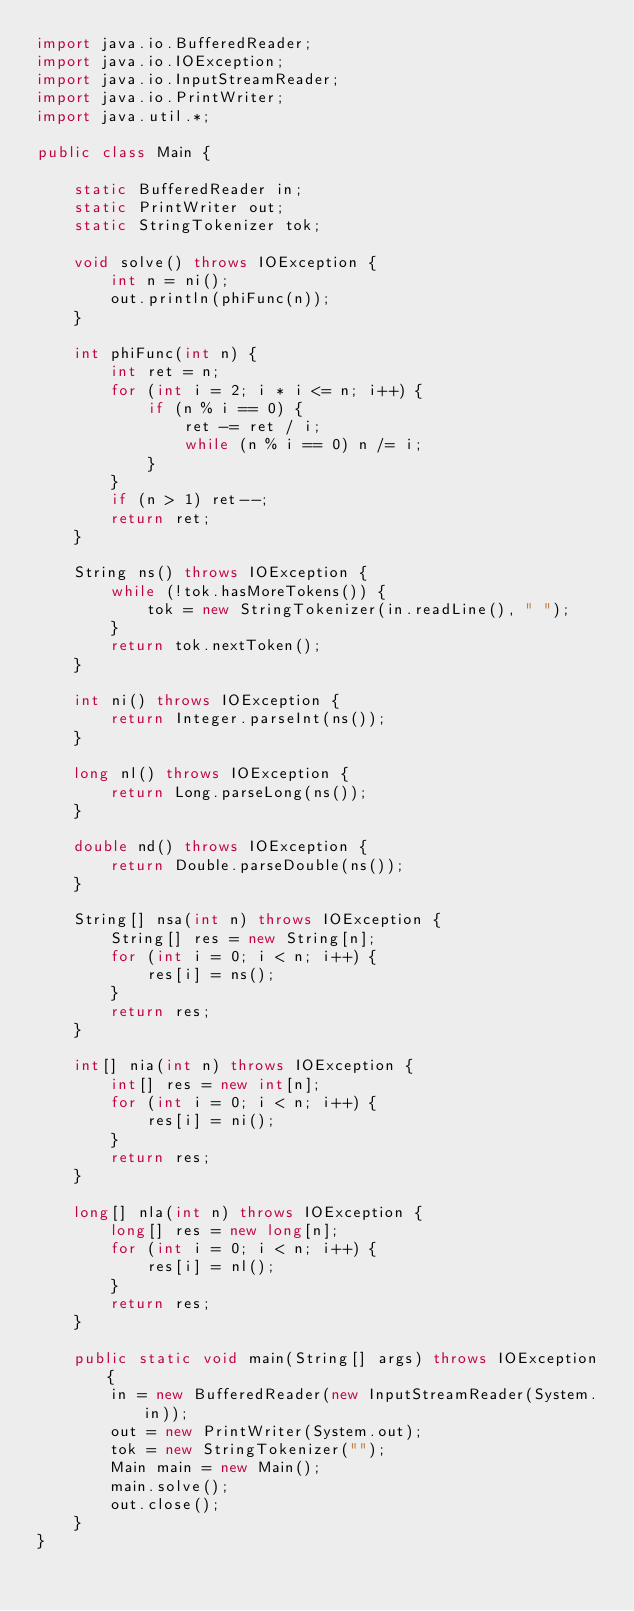<code> <loc_0><loc_0><loc_500><loc_500><_Java_>import java.io.BufferedReader;
import java.io.IOException;
import java.io.InputStreamReader;
import java.io.PrintWriter;
import java.util.*;

public class Main {

    static BufferedReader in;
    static PrintWriter out;
    static StringTokenizer tok;

    void solve() throws IOException {
        int n = ni();
        out.println(phiFunc(n));
    }

    int phiFunc(int n) {
        int ret = n;
        for (int i = 2; i * i <= n; i++) {
            if (n % i == 0) {
                ret -= ret / i;
                while (n % i == 0) n /= i;
            }
        }
        if (n > 1) ret--;
        return ret;
    }

    String ns() throws IOException {
        while (!tok.hasMoreTokens()) {
            tok = new StringTokenizer(in.readLine(), " ");
        }
        return tok.nextToken();
    }

    int ni() throws IOException {
        return Integer.parseInt(ns());
    }

    long nl() throws IOException {
        return Long.parseLong(ns());
    }

    double nd() throws IOException {
        return Double.parseDouble(ns());
    }

    String[] nsa(int n) throws IOException {
        String[] res = new String[n];
        for (int i = 0; i < n; i++) {
            res[i] = ns();
        }
        return res;
    }

    int[] nia(int n) throws IOException {
        int[] res = new int[n];
        for (int i = 0; i < n; i++) {
            res[i] = ni();
        }
        return res;
    }

    long[] nla(int n) throws IOException {
        long[] res = new long[n];
        for (int i = 0; i < n; i++) {
            res[i] = nl();
        }
        return res;
    }

    public static void main(String[] args) throws IOException {
        in = new BufferedReader(new InputStreamReader(System.in));
        out = new PrintWriter(System.out);
        tok = new StringTokenizer("");
        Main main = new Main();
        main.solve();
        out.close();
    }
}</code> 